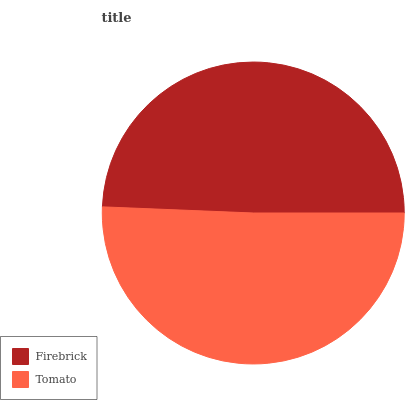Is Firebrick the minimum?
Answer yes or no. Yes. Is Tomato the maximum?
Answer yes or no. Yes. Is Tomato the minimum?
Answer yes or no. No. Is Tomato greater than Firebrick?
Answer yes or no. Yes. Is Firebrick less than Tomato?
Answer yes or no. Yes. Is Firebrick greater than Tomato?
Answer yes or no. No. Is Tomato less than Firebrick?
Answer yes or no. No. Is Tomato the high median?
Answer yes or no. Yes. Is Firebrick the low median?
Answer yes or no. Yes. Is Firebrick the high median?
Answer yes or no. No. Is Tomato the low median?
Answer yes or no. No. 